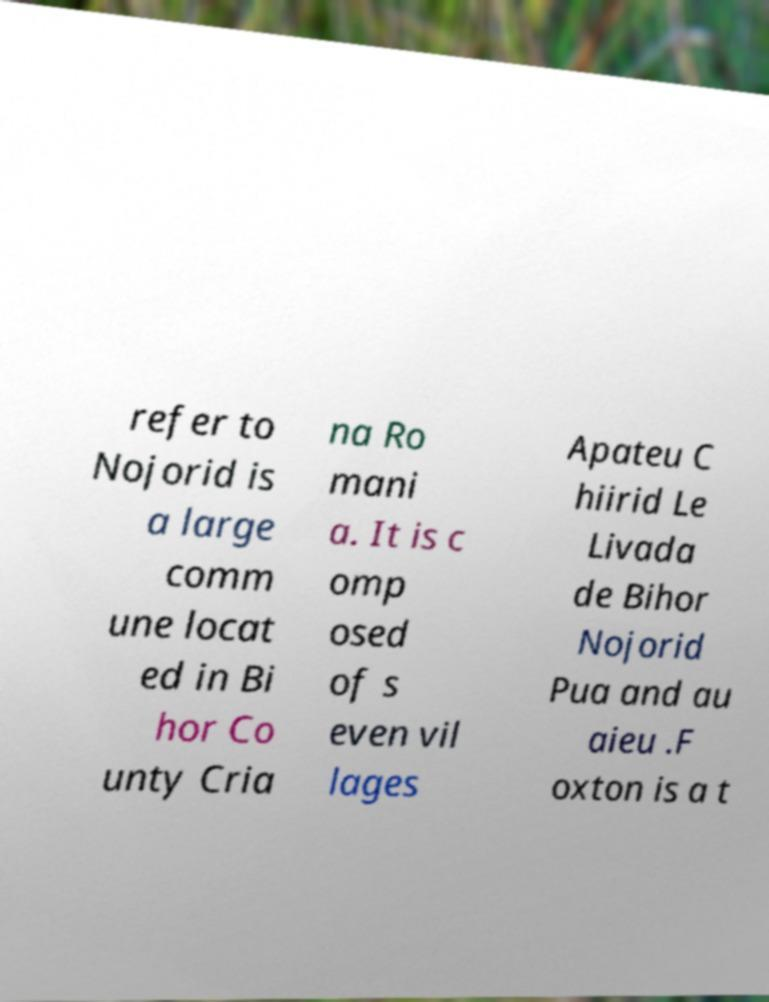Can you accurately transcribe the text from the provided image for me? refer to Nojorid is a large comm une locat ed in Bi hor Co unty Cria na Ro mani a. It is c omp osed of s even vil lages Apateu C hiirid Le Livada de Bihor Nojorid Pua and au aieu .F oxton is a t 